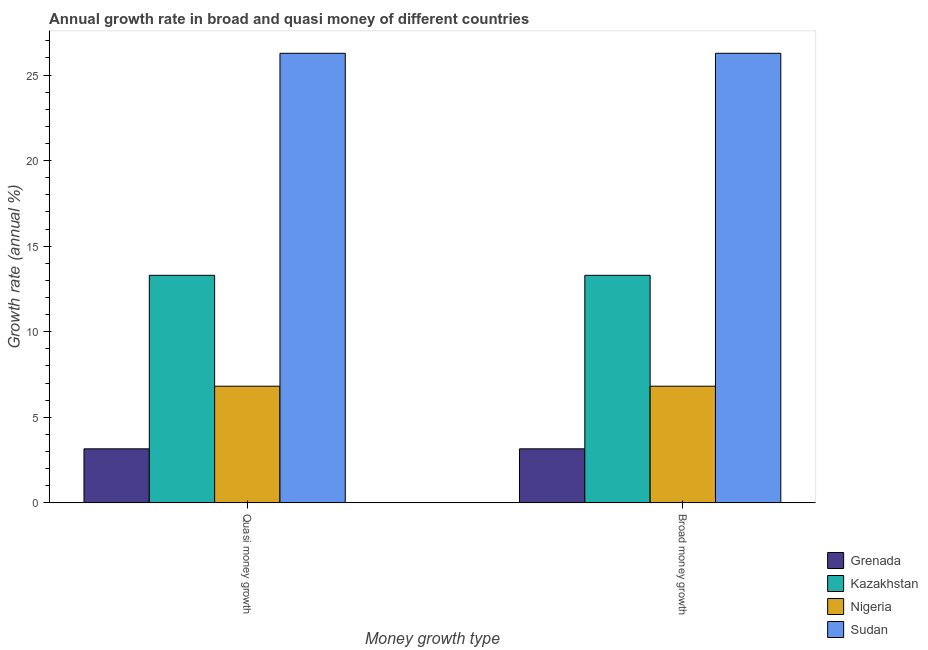How many different coloured bars are there?
Give a very brief answer. 4. How many groups of bars are there?
Offer a terse response. 2. How many bars are there on the 2nd tick from the left?
Make the answer very short. 4. What is the label of the 2nd group of bars from the left?
Offer a terse response. Broad money growth. What is the annual growth rate in broad money in Sudan?
Keep it short and to the point. 26.27. Across all countries, what is the maximum annual growth rate in broad money?
Give a very brief answer. 26.27. Across all countries, what is the minimum annual growth rate in broad money?
Offer a very short reply. 3.15. In which country was the annual growth rate in broad money maximum?
Your answer should be compact. Sudan. In which country was the annual growth rate in broad money minimum?
Your answer should be compact. Grenada. What is the total annual growth rate in broad money in the graph?
Offer a very short reply. 49.54. What is the difference between the annual growth rate in quasi money in Sudan and that in Kazakhstan?
Offer a very short reply. 12.98. What is the difference between the annual growth rate in broad money in Grenada and the annual growth rate in quasi money in Kazakhstan?
Provide a succinct answer. -10.14. What is the average annual growth rate in quasi money per country?
Keep it short and to the point. 12.38. In how many countries, is the annual growth rate in broad money greater than 26 %?
Ensure brevity in your answer.  1. What is the ratio of the annual growth rate in quasi money in Kazakhstan to that in Sudan?
Make the answer very short. 0.51. In how many countries, is the annual growth rate in broad money greater than the average annual growth rate in broad money taken over all countries?
Your response must be concise. 2. What does the 4th bar from the left in Quasi money growth represents?
Provide a succinct answer. Sudan. What does the 1st bar from the right in Broad money growth represents?
Your answer should be very brief. Sudan. How many countries are there in the graph?
Your answer should be very brief. 4. Are the values on the major ticks of Y-axis written in scientific E-notation?
Ensure brevity in your answer.  No. Does the graph contain any zero values?
Your answer should be compact. No. Does the graph contain grids?
Ensure brevity in your answer.  No. Where does the legend appear in the graph?
Provide a short and direct response. Bottom right. What is the title of the graph?
Offer a very short reply. Annual growth rate in broad and quasi money of different countries. What is the label or title of the X-axis?
Your answer should be very brief. Money growth type. What is the label or title of the Y-axis?
Ensure brevity in your answer.  Growth rate (annual %). What is the Growth rate (annual %) of Grenada in Quasi money growth?
Your response must be concise. 3.15. What is the Growth rate (annual %) in Kazakhstan in Quasi money growth?
Your answer should be very brief. 13.3. What is the Growth rate (annual %) in Nigeria in Quasi money growth?
Your answer should be compact. 6.82. What is the Growth rate (annual %) of Sudan in Quasi money growth?
Your answer should be compact. 26.27. What is the Growth rate (annual %) of Grenada in Broad money growth?
Make the answer very short. 3.15. What is the Growth rate (annual %) in Kazakhstan in Broad money growth?
Provide a short and direct response. 13.3. What is the Growth rate (annual %) of Nigeria in Broad money growth?
Offer a terse response. 6.82. What is the Growth rate (annual %) in Sudan in Broad money growth?
Offer a terse response. 26.27. Across all Money growth type, what is the maximum Growth rate (annual %) of Grenada?
Provide a short and direct response. 3.15. Across all Money growth type, what is the maximum Growth rate (annual %) in Kazakhstan?
Your answer should be very brief. 13.3. Across all Money growth type, what is the maximum Growth rate (annual %) in Nigeria?
Provide a short and direct response. 6.82. Across all Money growth type, what is the maximum Growth rate (annual %) in Sudan?
Make the answer very short. 26.27. Across all Money growth type, what is the minimum Growth rate (annual %) in Grenada?
Give a very brief answer. 3.15. Across all Money growth type, what is the minimum Growth rate (annual %) in Kazakhstan?
Ensure brevity in your answer.  13.3. Across all Money growth type, what is the minimum Growth rate (annual %) in Nigeria?
Make the answer very short. 6.82. Across all Money growth type, what is the minimum Growth rate (annual %) of Sudan?
Your answer should be compact. 26.27. What is the total Growth rate (annual %) in Grenada in the graph?
Your answer should be very brief. 6.31. What is the total Growth rate (annual %) in Kazakhstan in the graph?
Keep it short and to the point. 26.59. What is the total Growth rate (annual %) in Nigeria in the graph?
Ensure brevity in your answer.  13.63. What is the total Growth rate (annual %) of Sudan in the graph?
Provide a short and direct response. 52.55. What is the difference between the Growth rate (annual %) in Grenada in Quasi money growth and that in Broad money growth?
Provide a succinct answer. 0. What is the difference between the Growth rate (annual %) in Nigeria in Quasi money growth and that in Broad money growth?
Provide a short and direct response. 0. What is the difference between the Growth rate (annual %) in Sudan in Quasi money growth and that in Broad money growth?
Make the answer very short. 0. What is the difference between the Growth rate (annual %) in Grenada in Quasi money growth and the Growth rate (annual %) in Kazakhstan in Broad money growth?
Offer a terse response. -10.14. What is the difference between the Growth rate (annual %) in Grenada in Quasi money growth and the Growth rate (annual %) in Nigeria in Broad money growth?
Offer a terse response. -3.66. What is the difference between the Growth rate (annual %) of Grenada in Quasi money growth and the Growth rate (annual %) of Sudan in Broad money growth?
Offer a very short reply. -23.12. What is the difference between the Growth rate (annual %) in Kazakhstan in Quasi money growth and the Growth rate (annual %) in Nigeria in Broad money growth?
Your answer should be very brief. 6.48. What is the difference between the Growth rate (annual %) of Kazakhstan in Quasi money growth and the Growth rate (annual %) of Sudan in Broad money growth?
Your answer should be very brief. -12.98. What is the difference between the Growth rate (annual %) of Nigeria in Quasi money growth and the Growth rate (annual %) of Sudan in Broad money growth?
Offer a terse response. -19.46. What is the average Growth rate (annual %) in Grenada per Money growth type?
Keep it short and to the point. 3.15. What is the average Growth rate (annual %) of Kazakhstan per Money growth type?
Provide a succinct answer. 13.3. What is the average Growth rate (annual %) in Nigeria per Money growth type?
Make the answer very short. 6.82. What is the average Growth rate (annual %) in Sudan per Money growth type?
Keep it short and to the point. 26.27. What is the difference between the Growth rate (annual %) in Grenada and Growth rate (annual %) in Kazakhstan in Quasi money growth?
Ensure brevity in your answer.  -10.14. What is the difference between the Growth rate (annual %) in Grenada and Growth rate (annual %) in Nigeria in Quasi money growth?
Offer a terse response. -3.66. What is the difference between the Growth rate (annual %) in Grenada and Growth rate (annual %) in Sudan in Quasi money growth?
Your answer should be very brief. -23.12. What is the difference between the Growth rate (annual %) of Kazakhstan and Growth rate (annual %) of Nigeria in Quasi money growth?
Give a very brief answer. 6.48. What is the difference between the Growth rate (annual %) of Kazakhstan and Growth rate (annual %) of Sudan in Quasi money growth?
Your answer should be compact. -12.98. What is the difference between the Growth rate (annual %) in Nigeria and Growth rate (annual %) in Sudan in Quasi money growth?
Ensure brevity in your answer.  -19.46. What is the difference between the Growth rate (annual %) of Grenada and Growth rate (annual %) of Kazakhstan in Broad money growth?
Give a very brief answer. -10.14. What is the difference between the Growth rate (annual %) of Grenada and Growth rate (annual %) of Nigeria in Broad money growth?
Make the answer very short. -3.66. What is the difference between the Growth rate (annual %) of Grenada and Growth rate (annual %) of Sudan in Broad money growth?
Make the answer very short. -23.12. What is the difference between the Growth rate (annual %) in Kazakhstan and Growth rate (annual %) in Nigeria in Broad money growth?
Offer a very short reply. 6.48. What is the difference between the Growth rate (annual %) of Kazakhstan and Growth rate (annual %) of Sudan in Broad money growth?
Give a very brief answer. -12.98. What is the difference between the Growth rate (annual %) in Nigeria and Growth rate (annual %) in Sudan in Broad money growth?
Your response must be concise. -19.46. What is the ratio of the Growth rate (annual %) of Grenada in Quasi money growth to that in Broad money growth?
Keep it short and to the point. 1. What is the difference between the highest and the second highest Growth rate (annual %) of Nigeria?
Offer a very short reply. 0. What is the difference between the highest and the second highest Growth rate (annual %) of Sudan?
Your answer should be very brief. 0. 